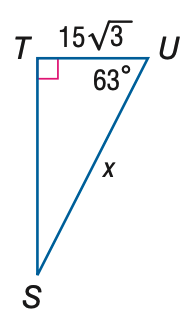Question: Find x. Round to the nearest tenth.
Choices:
A. 11.8
B. 29.2
C. 51.0
D. 57.2
Answer with the letter. Answer: D 